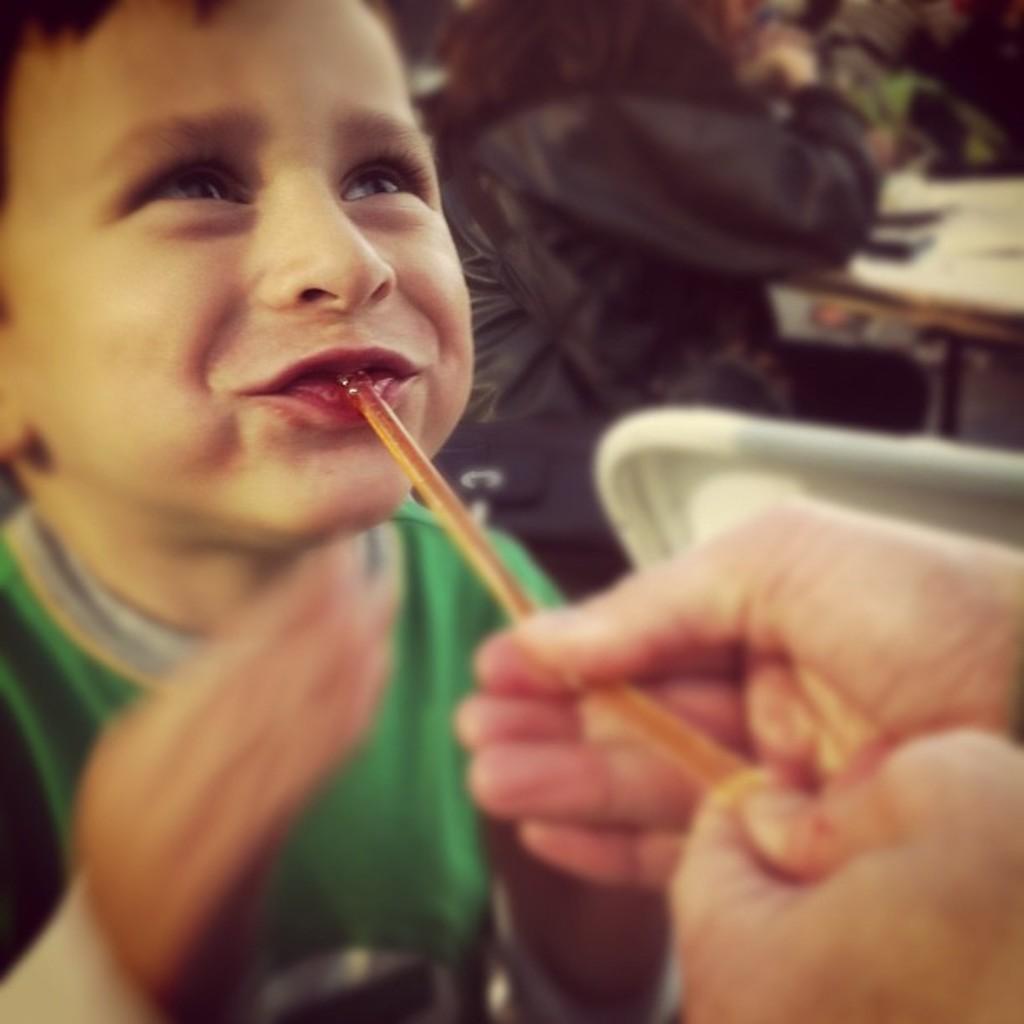How would you summarize this image in a sentence or two? This image consists of a kid. In his mouth there is a straw. To the right, the person is holding that straw. In the background, there is a woman wearing black jacket is sitting in a chair. 